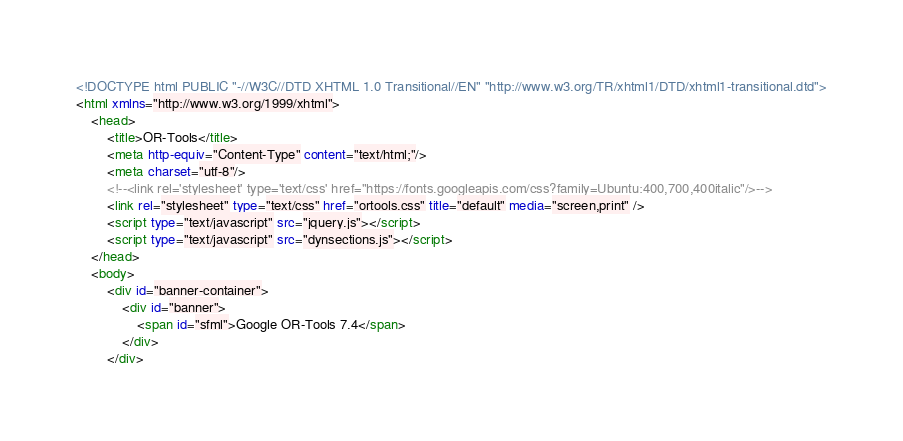Convert code to text. <code><loc_0><loc_0><loc_500><loc_500><_HTML_><!DOCTYPE html PUBLIC "-//W3C//DTD XHTML 1.0 Transitional//EN" "http://www.w3.org/TR/xhtml1/DTD/xhtml1-transitional.dtd">
<html xmlns="http://www.w3.org/1999/xhtml">
    <head>
        <title>OR-Tools</title>
        <meta http-equiv="Content-Type" content="text/html;"/>
        <meta charset="utf-8"/>
        <!--<link rel='stylesheet' type='text/css' href="https://fonts.googleapis.com/css?family=Ubuntu:400,700,400italic"/>-->
        <link rel="stylesheet" type="text/css" href="ortools.css" title="default" media="screen,print" />
        <script type="text/javascript" src="jquery.js"></script>
        <script type="text/javascript" src="dynsections.js"></script>
    </head>
    <body>
        <div id="banner-container">
            <div id="banner">
                <span id="sfml">Google OR-Tools 7.4</span>
            </div>
        </div></code> 